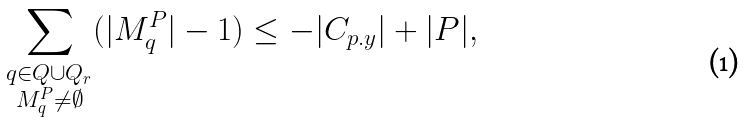<formula> <loc_0><loc_0><loc_500><loc_500>\sum _ { \substack { q \in Q \cup Q _ { r } \\ M ^ { P } _ { q } \ne \emptyset } } ( | M ^ { P } _ { q } | - 1 ) \leq - | C _ { p . y } | + | P | ,</formula> 